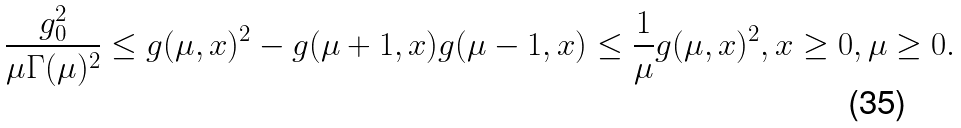<formula> <loc_0><loc_0><loc_500><loc_500>\frac { g _ { 0 } ^ { 2 } } { \mu \Gamma ( \mu ) ^ { 2 } } \leq g ( \mu , x ) ^ { 2 } - g ( \mu + 1 , x ) g ( \mu - 1 , x ) \leq \frac { 1 } { \mu } g ( \mu , x ) ^ { 2 } , x \geq { 0 } , \mu \geq { 0 } .</formula> 